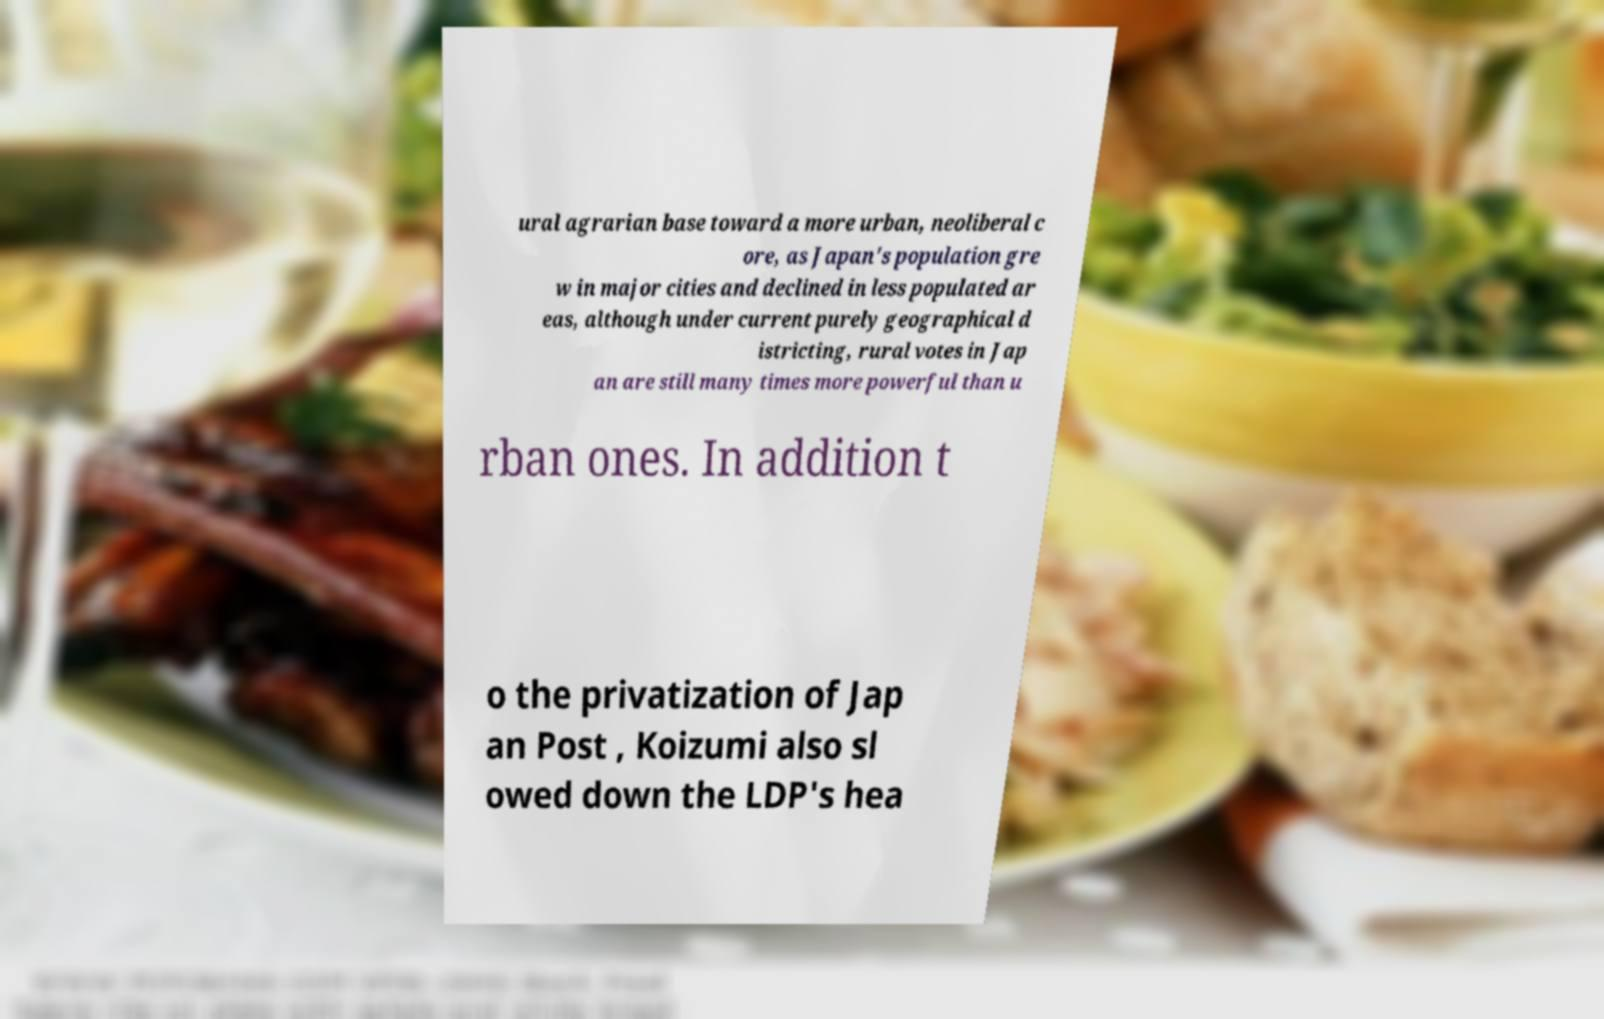There's text embedded in this image that I need extracted. Can you transcribe it verbatim? ural agrarian base toward a more urban, neoliberal c ore, as Japan's population gre w in major cities and declined in less populated ar eas, although under current purely geographical d istricting, rural votes in Jap an are still many times more powerful than u rban ones. In addition t o the privatization of Jap an Post , Koizumi also sl owed down the LDP's hea 